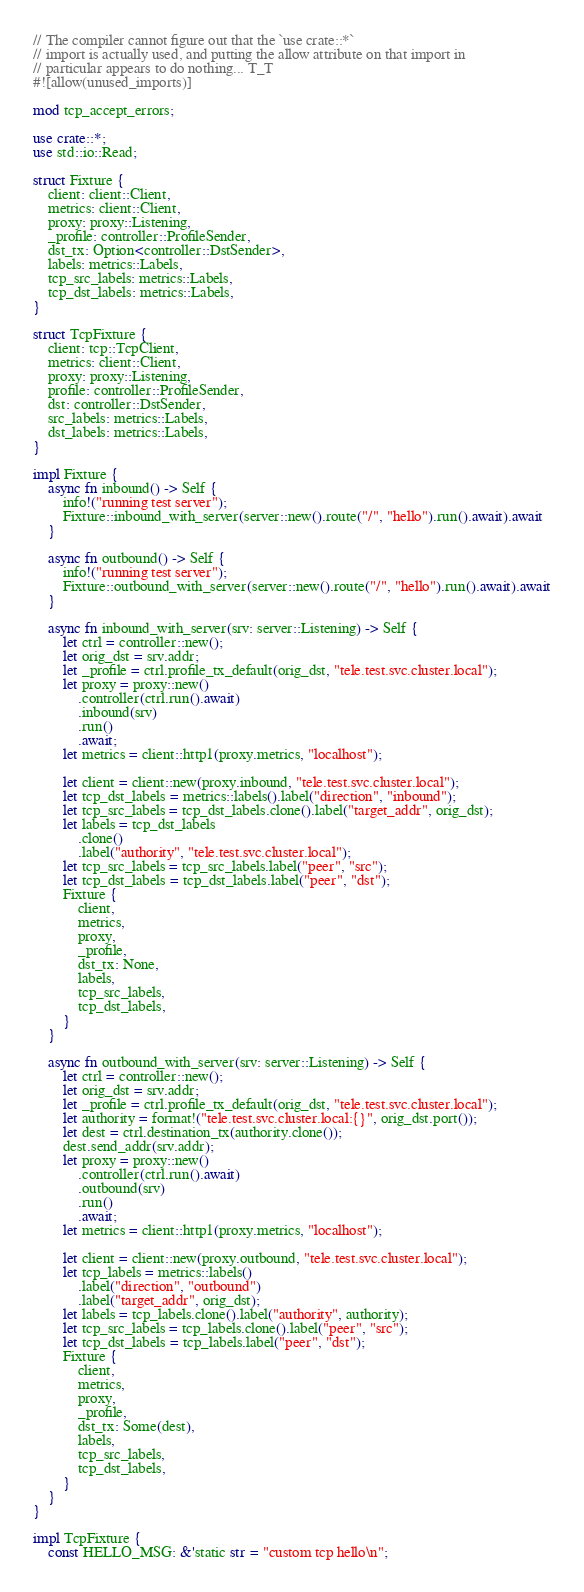Convert code to text. <code><loc_0><loc_0><loc_500><loc_500><_Rust_>// The compiler cannot figure out that the `use crate::*`
// import is actually used, and putting the allow attribute on that import in
// particular appears to do nothing... T_T
#![allow(unused_imports)]

mod tcp_accept_errors;

use crate::*;
use std::io::Read;

struct Fixture {
    client: client::Client,
    metrics: client::Client,
    proxy: proxy::Listening,
    _profile: controller::ProfileSender,
    dst_tx: Option<controller::DstSender>,
    labels: metrics::Labels,
    tcp_src_labels: metrics::Labels,
    tcp_dst_labels: metrics::Labels,
}

struct TcpFixture {
    client: tcp::TcpClient,
    metrics: client::Client,
    proxy: proxy::Listening,
    profile: controller::ProfileSender,
    dst: controller::DstSender,
    src_labels: metrics::Labels,
    dst_labels: metrics::Labels,
}

impl Fixture {
    async fn inbound() -> Self {
        info!("running test server");
        Fixture::inbound_with_server(server::new().route("/", "hello").run().await).await
    }

    async fn outbound() -> Self {
        info!("running test server");
        Fixture::outbound_with_server(server::new().route("/", "hello").run().await).await
    }

    async fn inbound_with_server(srv: server::Listening) -> Self {
        let ctrl = controller::new();
        let orig_dst = srv.addr;
        let _profile = ctrl.profile_tx_default(orig_dst, "tele.test.svc.cluster.local");
        let proxy = proxy::new()
            .controller(ctrl.run().await)
            .inbound(srv)
            .run()
            .await;
        let metrics = client::http1(proxy.metrics, "localhost");

        let client = client::new(proxy.inbound, "tele.test.svc.cluster.local");
        let tcp_dst_labels = metrics::labels().label("direction", "inbound");
        let tcp_src_labels = tcp_dst_labels.clone().label("target_addr", orig_dst);
        let labels = tcp_dst_labels
            .clone()
            .label("authority", "tele.test.svc.cluster.local");
        let tcp_src_labels = tcp_src_labels.label("peer", "src");
        let tcp_dst_labels = tcp_dst_labels.label("peer", "dst");
        Fixture {
            client,
            metrics,
            proxy,
            _profile,
            dst_tx: None,
            labels,
            tcp_src_labels,
            tcp_dst_labels,
        }
    }

    async fn outbound_with_server(srv: server::Listening) -> Self {
        let ctrl = controller::new();
        let orig_dst = srv.addr;
        let _profile = ctrl.profile_tx_default(orig_dst, "tele.test.svc.cluster.local");
        let authority = format!("tele.test.svc.cluster.local:{}", orig_dst.port());
        let dest = ctrl.destination_tx(authority.clone());
        dest.send_addr(srv.addr);
        let proxy = proxy::new()
            .controller(ctrl.run().await)
            .outbound(srv)
            .run()
            .await;
        let metrics = client::http1(proxy.metrics, "localhost");

        let client = client::new(proxy.outbound, "tele.test.svc.cluster.local");
        let tcp_labels = metrics::labels()
            .label("direction", "outbound")
            .label("target_addr", orig_dst);
        let labels = tcp_labels.clone().label("authority", authority);
        let tcp_src_labels = tcp_labels.clone().label("peer", "src");
        let tcp_dst_labels = tcp_labels.label("peer", "dst");
        Fixture {
            client,
            metrics,
            proxy,
            _profile,
            dst_tx: Some(dest),
            labels,
            tcp_src_labels,
            tcp_dst_labels,
        }
    }
}

impl TcpFixture {
    const HELLO_MSG: &'static str = "custom tcp hello\n";</code> 